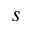Convert formula to latex. <formula><loc_0><loc_0><loc_500><loc_500>s</formula> 